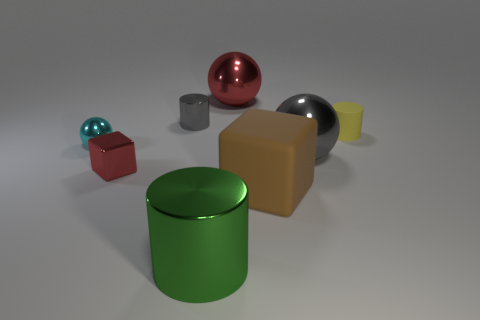Subtract all gray cylinders. How many cylinders are left? 2 Subtract all spheres. How many objects are left? 5 Add 1 tiny yellow cylinders. How many objects exist? 9 Subtract all gray cylinders. How many cylinders are left? 2 Add 8 tiny rubber cylinders. How many tiny rubber cylinders exist? 9 Subtract 0 purple cylinders. How many objects are left? 8 Subtract 2 blocks. How many blocks are left? 0 Subtract all blue cylinders. Subtract all gray cubes. How many cylinders are left? 3 Subtract all green balls. How many cyan cylinders are left? 0 Subtract all yellow rubber objects. Subtract all big gray shiny spheres. How many objects are left? 6 